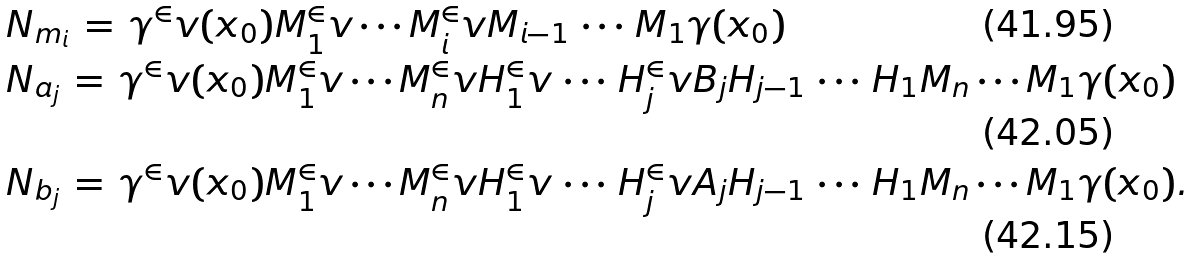<formula> <loc_0><loc_0><loc_500><loc_500>& N _ { m _ { i } } \, = \, \gamma ^ { \in } v ( x _ { 0 } ) M _ { 1 } ^ { \in } v \cdots M _ { i } ^ { \in } v M _ { i - 1 } \, \cdots \, M _ { 1 } \gamma ( x _ { 0 } ) \\ & N _ { a _ { j } } \, = \, \gamma ^ { \in } v ( x _ { 0 } ) M _ { 1 } ^ { \in } v \cdots M _ { n } ^ { \in } v H _ { 1 } ^ { \in } v \, \cdots \, H _ { j } ^ { \in } v B _ { j } H _ { j - 1 } \, \cdots \, H _ { 1 } M _ { n } \cdots M _ { 1 } \gamma ( x _ { 0 } ) \\ & N _ { b _ { j } } \, = \, \gamma ^ { \in } v ( x _ { 0 } ) M _ { 1 } ^ { \in } v \cdots M _ { n } ^ { \in } v H _ { 1 } ^ { \in } v \, \cdots \, H _ { j } ^ { \in } v A _ { j } H _ { j - 1 } \, \cdots \, H _ { 1 } M _ { n } \cdots M _ { 1 } \gamma ( x _ { 0 } ) .</formula> 